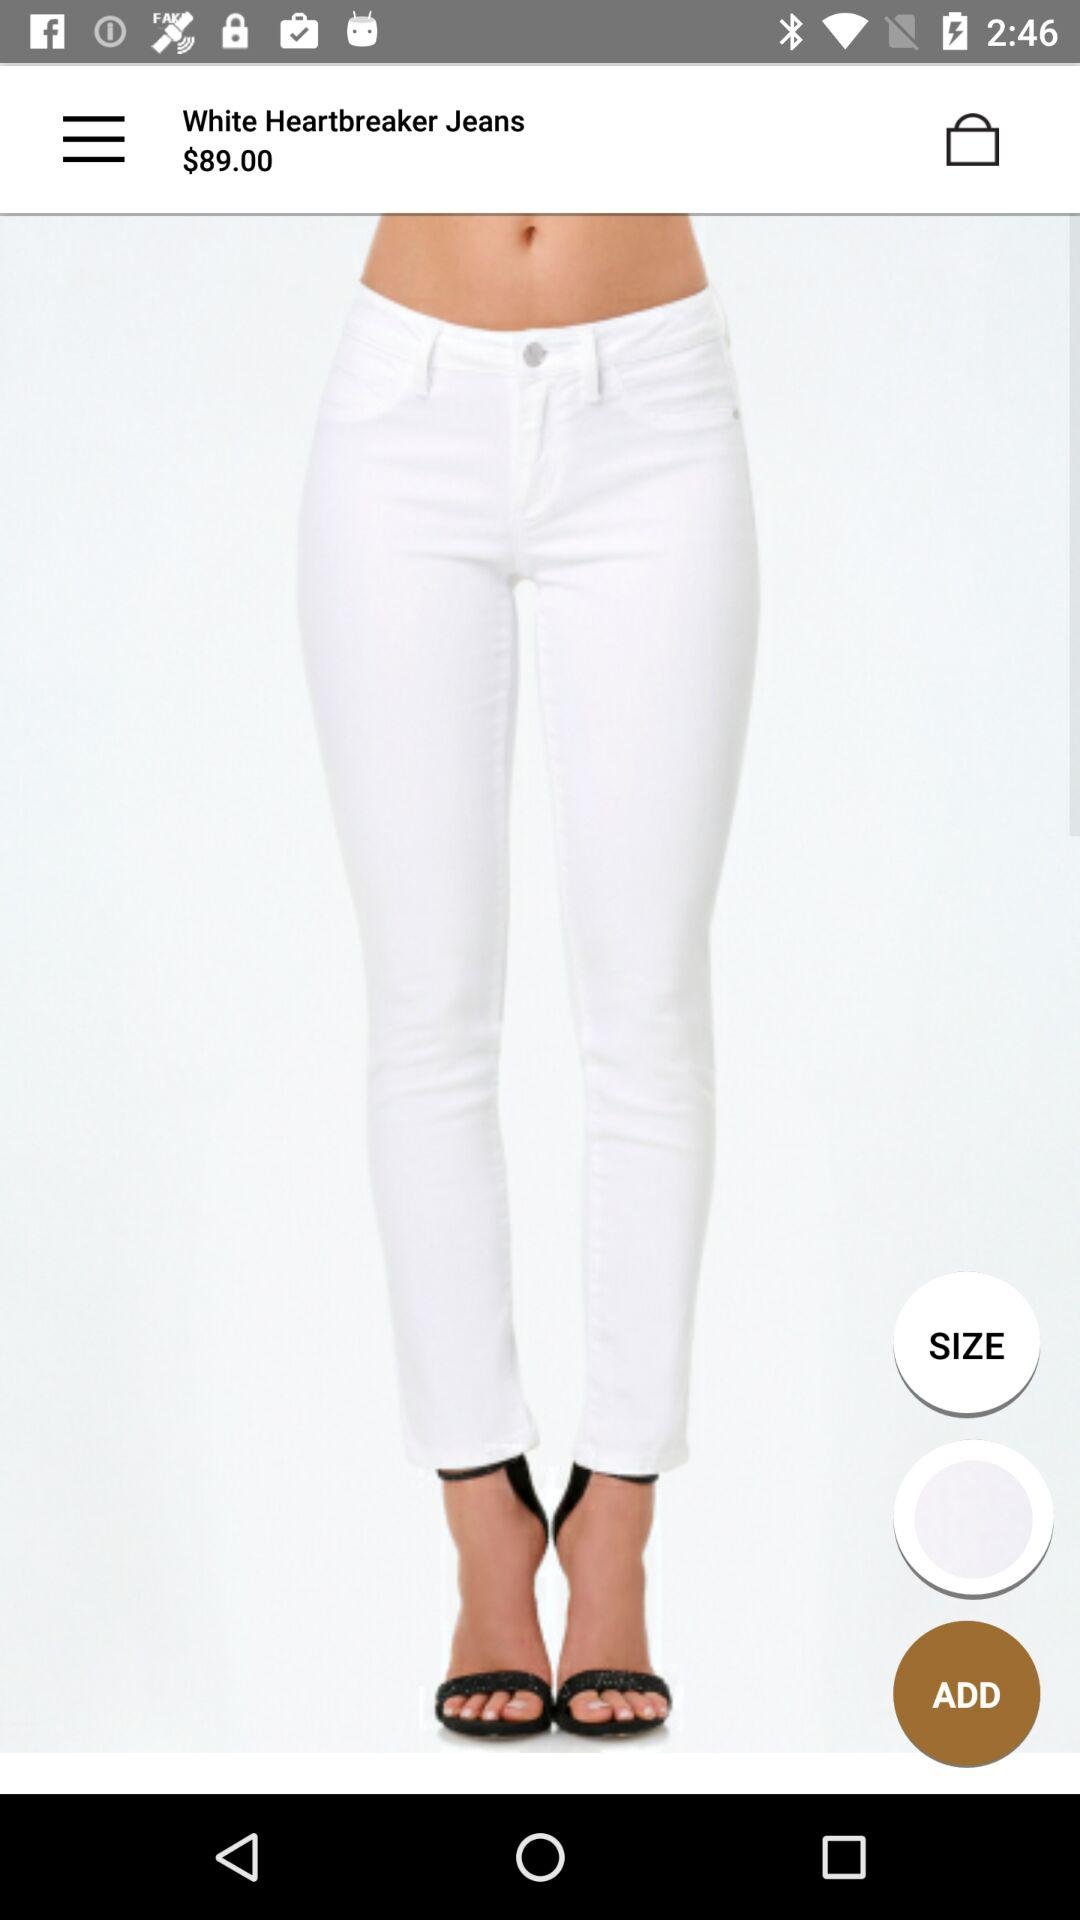What is the currency of the price? The currency of the price is dollars. 